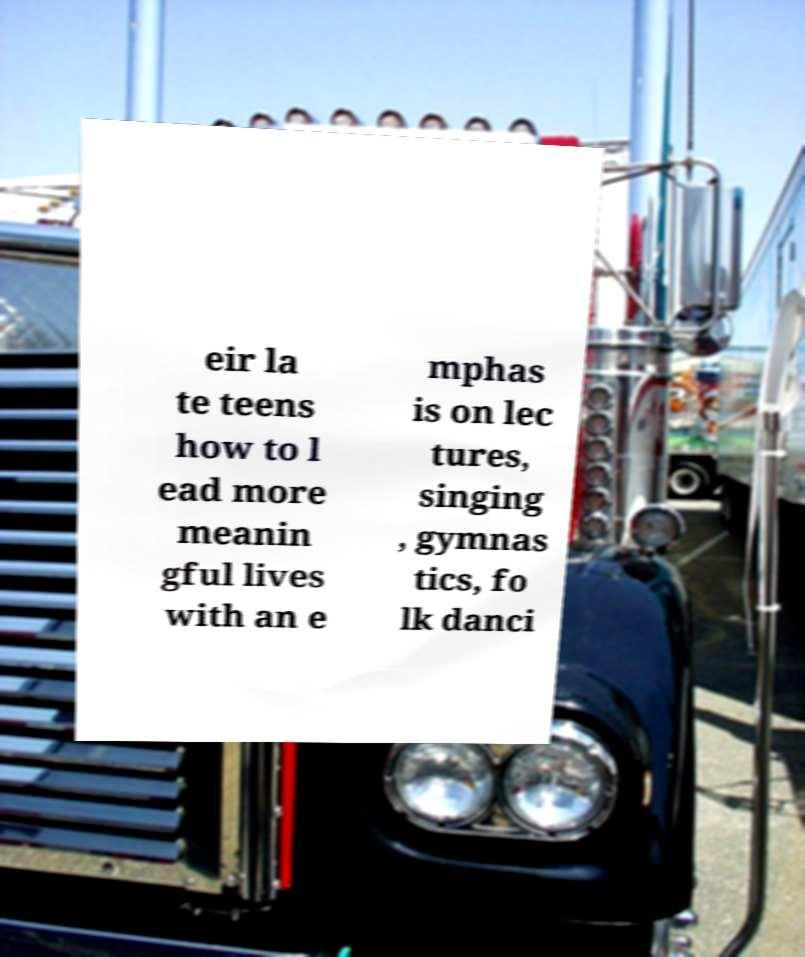What messages or text are displayed in this image? I need them in a readable, typed format. eir la te teens how to l ead more meanin gful lives with an e mphas is on lec tures, singing , gymnas tics, fo lk danci 